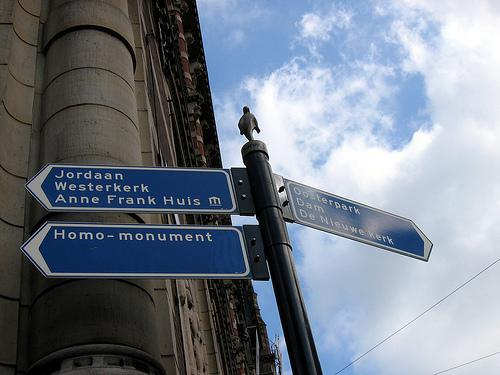Question: what direction is is the Oosterpark?
Choices:
A. Left.
B. Straight ahead.
C. Straight then left.
D. Right.
Answer with the letter. Answer: D Question: what direction is Anne Frank's house?
Choices:
A. Right.
B. East.
C. South.
D. Left.
Answer with the letter. Answer: D Question: where was this photo taken?
Choices:
A. In the backyard.
B. At the graduation.
C. An Amsterdam street.
D. At the wedding.
Answer with the letter. Answer: C Question: who lived in a house on the left?
Choices:
A. My mother.
B. Anne Frank.
C. The Smith's.
D. Uncle George.
Answer with the letter. Answer: B Question: how many directional signs can be seen?
Choices:
A. Four.
B. Five.
C. Three.
D. Six.
Answer with the letter. Answer: C Question: what can be seen behind the signs?
Choices:
A. Dogs.
B. Trees.
C. Flowers.
D. Buildings.
Answer with the letter. Answer: D 